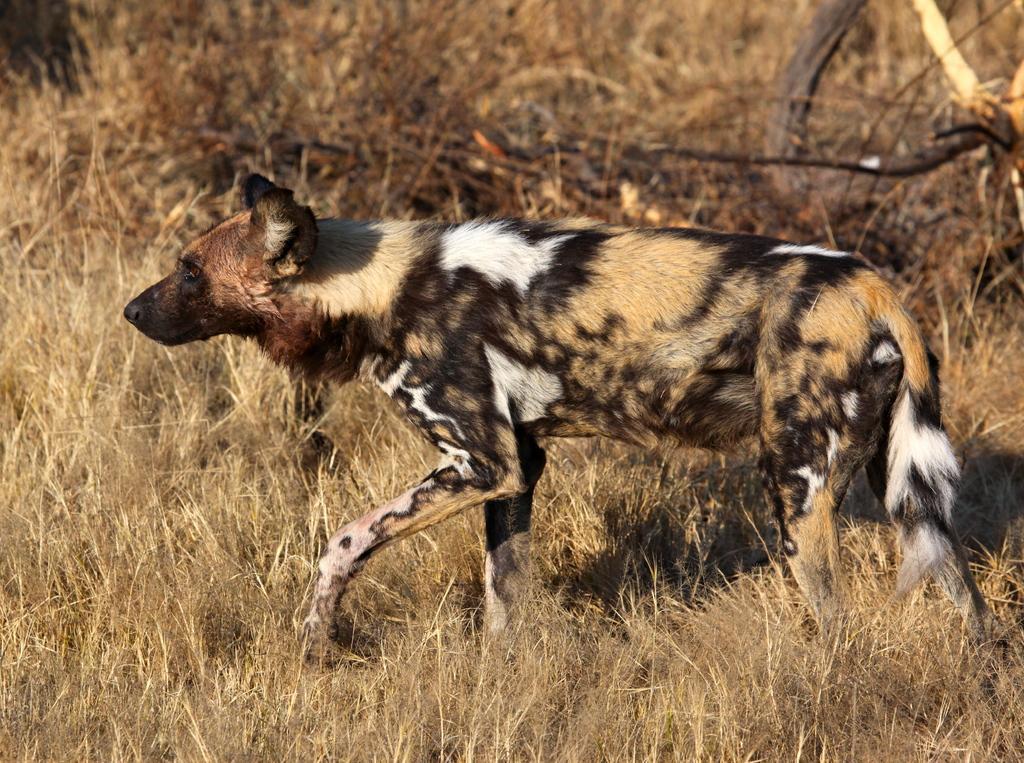In one or two sentences, can you explain what this image depicts? In this image, I can see a hyena walking. This is the dried grass. In the background, I can see the branches. 